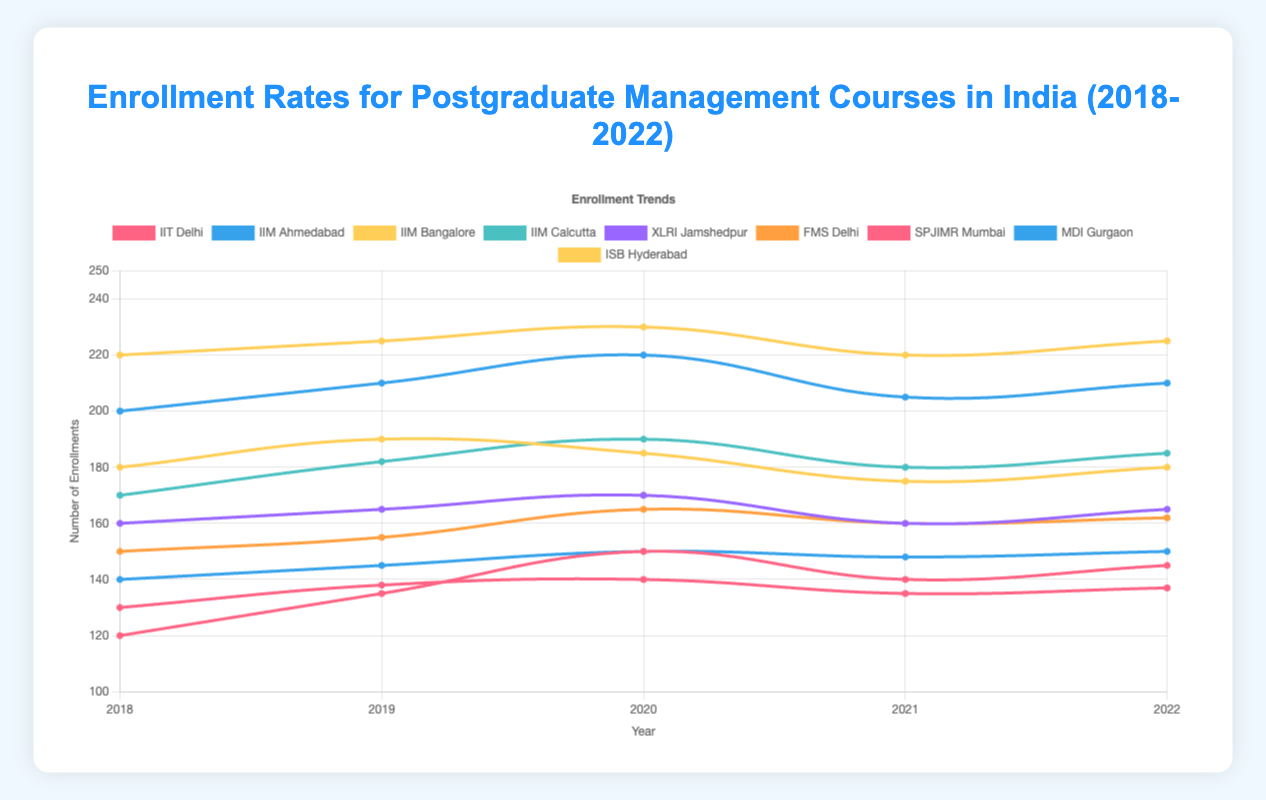Which institution had the highest enrollment rate in 2020? Look at the data points for each institution in the year 2020. ISB Hyderabad has the highest enrollment rate with 230 enrollments.
Answer: ISB Hyderabad Which years saw a decrease in enrollment for IIM Bangalore? Check the data points for IIM Bangalore across the years. Enrollment decreased from 190 in 2019 to 185 in 2020 and again from 175 in 2021 to 180 in 2022 compared to the previous year.
Answer: 2020, 2021 What's the average enrollment rate for FMS Delhi over the five years? Add the enrollment numbers for FMS Delhi and divide by the number of years. (150 + 155 + 165 + 160 + 162) / 5 = 158.4
Answer: 158.4 Which institution showed the most consistent enrollment rates over the five years, and what seems to be this rate? Check each institution’s enrollment variability. XLRI Jamshedpur’s enrollment rates (160, 165, 170, 160, 165) appear the most consistent, staying within a tight range of 160-170.
Answer: XLRI Jamshedpur, 160-170 In which year did IIT Delhi observe its highest enrollment rate? Look at the enrollment data for IIT Delhi. The highest point is in 2020 with 150 enrollments.
Answer: 2020 How do the 2018 and 2022 enrollment rates for MDI Gurgaon compare? Compare the enrollment number for MDI Gurgaon in 2018 and 2022, which are 140 and 150 respectively. Enrollment increased from 140 to 150.
Answer: 2022 had higher enrollment What is the total enrollment for ISB Hyderabad over these five years? Sum the enrollment numbers for ISB Hyderabad: 220 + 225 + 230 + 220 + 225 = 1120.
Answer: 1120 Which year had the lowest enrollment rate for SPJIMR Mumbai and what was it? Look at the data points for SPJIMR Mumbai. The lowest enrollment rate is in 2021 with 135 enrollments.
Answer: 2021, 135 Compare the enrollment trends of IIM Ahmedabad and IIM Calcutta in 2019. Which institution had a higher enrollment rate? Look at the 2019 data for IIM Ahmedabad and IIM Calcutta. IIM Ahmedabad had higher enrollment with 210 compared to IIM Calcutta's 182.
Answer: IIM Ahmedabad 